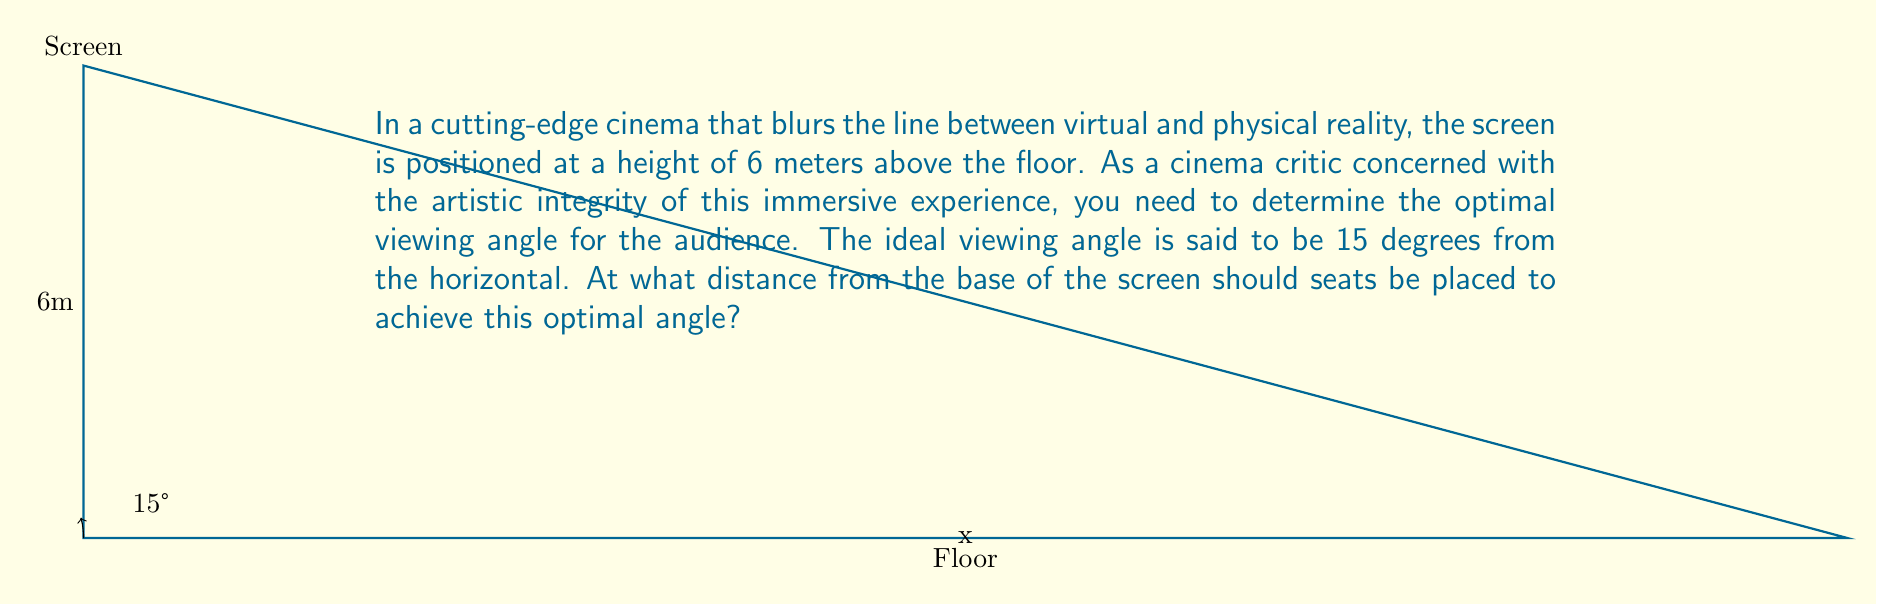Give your solution to this math problem. Let's approach this step-by-step using trigonometric functions:

1) We can model this scenario as a right-angled triangle, where:
   - The vertical side is the height of the screen (6 meters)
   - The horizontal side is the distance we're trying to find (let's call it x)
   - The angle between the horizontal and the line of sight is 15°

2) In this triangle, we can use the tangent function:

   $$\tan(\theta) = \frac{\text{opposite}}{\text{adjacent}}$$

3) Plugging in our values:

   $$\tan(15°) = \frac{6}{x}$$

4) To solve for x, we need to rearrange this equation:

   $$x = \frac{6}{\tan(15°)}$$

5) Now we can calculate:
   
   $$x = \frac{6}{\tan(15°)} \approx 22.3936$$

6) Rounding to two decimal places for practical purposes:

   $$x \approx 22.39 \text{ meters}$$

This distance ensures that the audience experiences the optimal viewing angle, maintaining the artistic integrity of the cinema experience while balancing the immersive aspects of the virtual-physical reality blend.
Answer: $22.39 \text{ meters}$ 